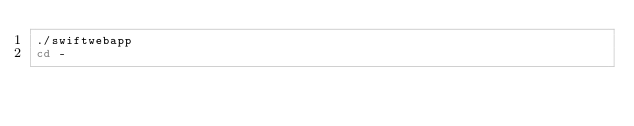Convert code to text. <code><loc_0><loc_0><loc_500><loc_500><_Bash_>./swiftwebapp
cd -
</code> 